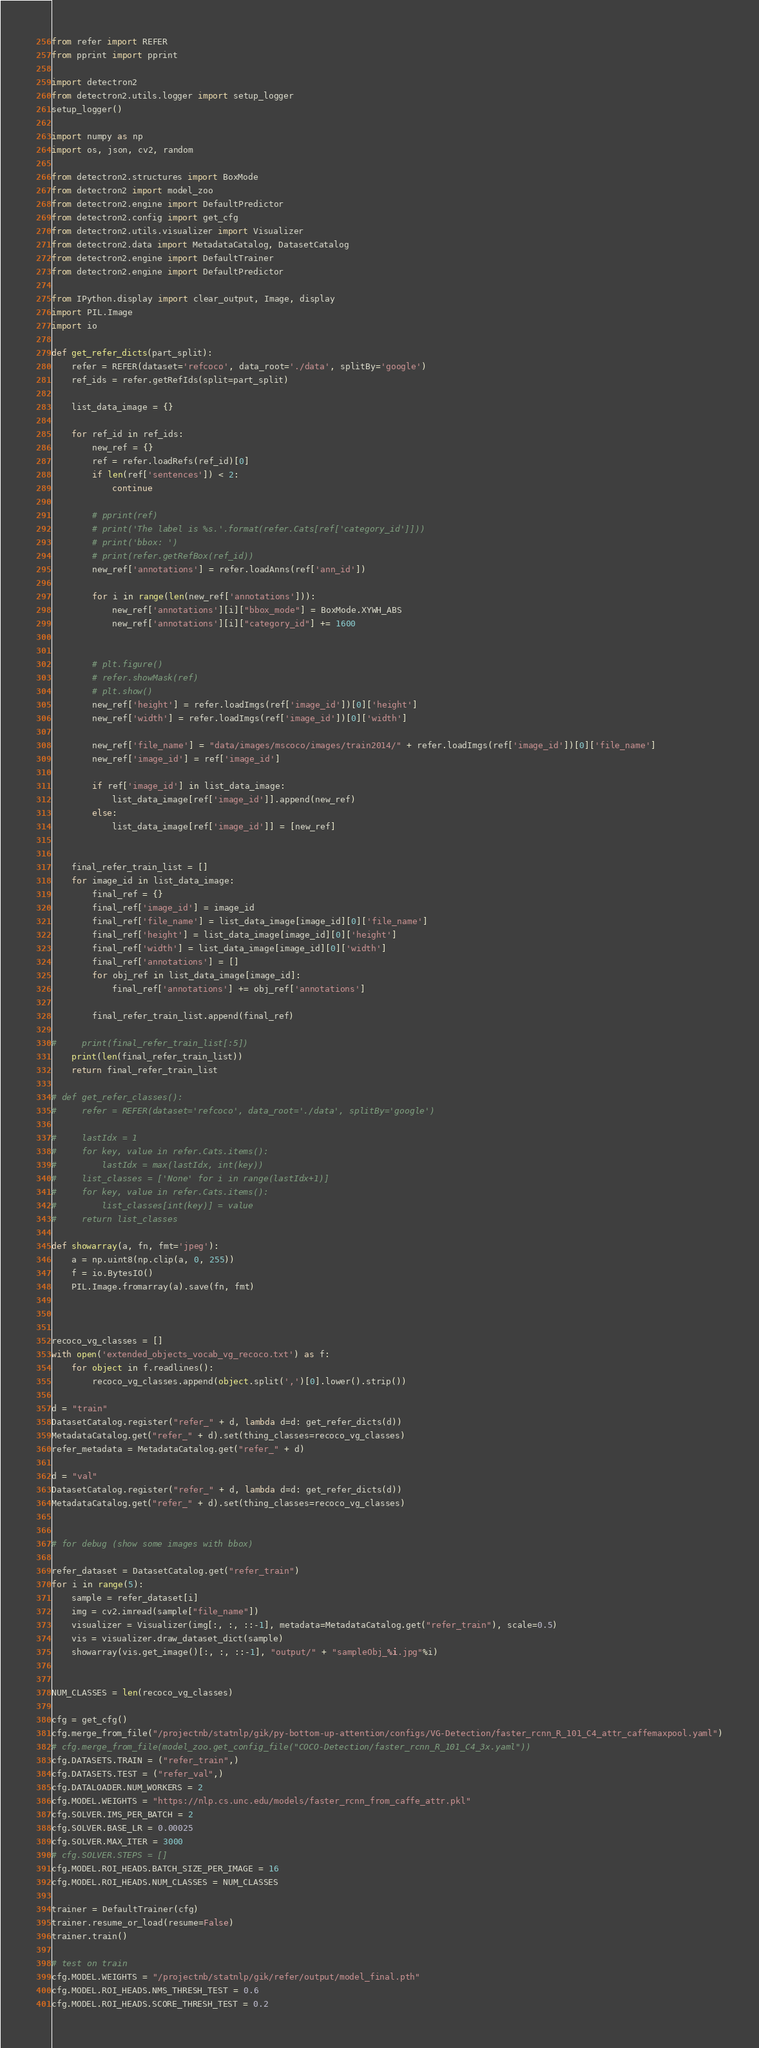<code> <loc_0><loc_0><loc_500><loc_500><_Python_>from refer import REFER 
from pprint import pprint

import detectron2
from detectron2.utils.logger import setup_logger
setup_logger()

import numpy as np
import os, json, cv2, random

from detectron2.structures import BoxMode
from detectron2 import model_zoo
from detectron2.engine import DefaultPredictor
from detectron2.config import get_cfg
from detectron2.utils.visualizer import Visualizer
from detectron2.data import MetadataCatalog, DatasetCatalog
from detectron2.engine import DefaultTrainer
from detectron2.engine import DefaultPredictor

from IPython.display import clear_output, Image, display
import PIL.Image
import io

def get_refer_dicts(part_split):
    refer = REFER(dataset='refcoco', data_root='./data', splitBy='google')
    ref_ids = refer.getRefIds(split=part_split)
    
    list_data_image = {}

    for ref_id in ref_ids:
        new_ref = {}
        ref = refer.loadRefs(ref_id)[0]
        if len(ref['sentences']) < 2:
            continue

        # pprint(ref)
        # print('The label is %s.'.format(refer.Cats[ref['category_id']]))
        # print('bbox: ')
        # print(refer.getRefBox(ref_id))
        new_ref['annotations'] = refer.loadAnns(ref['ann_id'])
        
        for i in range(len(new_ref['annotations'])):
            new_ref['annotations'][i]["bbox_mode"] = BoxMode.XYWH_ABS
            new_ref['annotations'][i]["category_id"] += 1600


        # plt.figure()
        # refer.showMask(ref)
        # plt.show()
        new_ref['height'] = refer.loadImgs(ref['image_id'])[0]['height']
        new_ref['width'] = refer.loadImgs(ref['image_id'])[0]['width']

        new_ref['file_name'] = "data/images/mscoco/images/train2014/" + refer.loadImgs(ref['image_id'])[0]['file_name']
        new_ref['image_id'] = ref['image_id']
        
        if ref['image_id'] in list_data_image:
            list_data_image[ref['image_id']].append(new_ref)
        else:
            list_data_image[ref['image_id']] = [new_ref]
        
        
    final_refer_train_list = []
    for image_id in list_data_image:
        final_ref = {}
        final_ref['image_id'] = image_id
        final_ref['file_name'] = list_data_image[image_id][0]['file_name']
        final_ref['height'] = list_data_image[image_id][0]['height']
        final_ref['width'] = list_data_image[image_id][0]['width']
        final_ref['annotations'] = []
        for obj_ref in list_data_image[image_id]:
            final_ref['annotations'] += obj_ref['annotations']
            
        final_refer_train_list.append(final_ref)
        
#     print(final_refer_train_list[:5])
    print(len(final_refer_train_list))
    return final_refer_train_list

# def get_refer_classes():
#     refer = REFER(dataset='refcoco', data_root='./data', splitBy='google')
    
#     lastIdx = 1
#     for key, value in refer.Cats.items():
#         lastIdx = max(lastIdx, int(key))
#     list_classes = ['None' for i in range(lastIdx+1)]
#     for key, value in refer.Cats.items():
#         list_classes[int(key)] = value
#     return list_classes

def showarray(a, fn, fmt='jpeg'):
    a = np.uint8(np.clip(a, 0, 255))
    f = io.BytesIO()
    PIL.Image.fromarray(a).save(fn, fmt)



recoco_vg_classes = []
with open('extended_objects_vocab_vg_recoco.txt') as f:
    for object in f.readlines():
        recoco_vg_classes.append(object.split(',')[0].lower().strip())

d = "train"
DatasetCatalog.register("refer_" + d, lambda d=d: get_refer_dicts(d))
MetadataCatalog.get("refer_" + d).set(thing_classes=recoco_vg_classes)
refer_metadata = MetadataCatalog.get("refer_" + d)

d = "val"
DatasetCatalog.register("refer_" + d, lambda d=d: get_refer_dicts(d))
MetadataCatalog.get("refer_" + d).set(thing_classes=recoco_vg_classes)


# for debug (show some images with bbox)

refer_dataset = DatasetCatalog.get("refer_train")
for i in range(5):
    sample = refer_dataset[i]
    img = cv2.imread(sample["file_name"])
    visualizer = Visualizer(img[:, :, ::-1], metadata=MetadataCatalog.get("refer_train"), scale=0.5)
    vis = visualizer.draw_dataset_dict(sample)
    showarray(vis.get_image()[:, :, ::-1], "output/" + "sampleObj_%i.jpg"%i)


NUM_CLASSES = len(recoco_vg_classes)

cfg = get_cfg()
cfg.merge_from_file("/projectnb/statnlp/gik/py-bottom-up-attention/configs/VG-Detection/faster_rcnn_R_101_C4_attr_caffemaxpool.yaml")
# cfg.merge_from_file(model_zoo.get_config_file("COCO-Detection/faster_rcnn_R_101_C4_3x.yaml"))
cfg.DATASETS.TRAIN = ("refer_train",)
cfg.DATASETS.TEST = ("refer_val",)
cfg.DATALOADER.NUM_WORKERS = 2
cfg.MODEL.WEIGHTS = "https://nlp.cs.unc.edu/models/faster_rcnn_from_caffe_attr.pkl"
cfg.SOLVER.IMS_PER_BATCH = 2
cfg.SOLVER.BASE_LR = 0.00025 
cfg.SOLVER.MAX_ITER = 3000  
# cfg.SOLVER.STEPS = []        
cfg.MODEL.ROI_HEADS.BATCH_SIZE_PER_IMAGE = 16
cfg.MODEL.ROI_HEADS.NUM_CLASSES = NUM_CLASSES

trainer = DefaultTrainer(cfg) 
trainer.resume_or_load(resume=False)
trainer.train()

# test on train
cfg.MODEL.WEIGHTS = "/projectnb/statnlp/gik/refer/output/model_final.pth"
cfg.MODEL.ROI_HEADS.NMS_THRESH_TEST = 0.6
cfg.MODEL.ROI_HEADS.SCORE_THRESH_TEST = 0.2</code> 